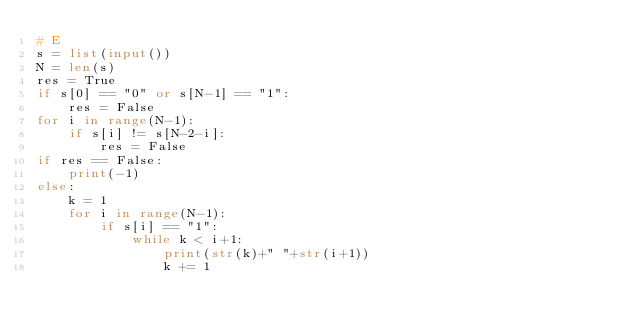Convert code to text. <code><loc_0><loc_0><loc_500><loc_500><_Python_># E
s = list(input())
N = len(s)
res = True
if s[0] == "0" or s[N-1] == "1":
    res = False
for i in range(N-1):
    if s[i] != s[N-2-i]:
        res = False
if res == False:
    print(-1)
else:
    k = 1
    for i in range(N-1):
        if s[i] == "1":
            while k < i+1:
                print(str(k)+" "+str(i+1))
                k += 1
            </code> 